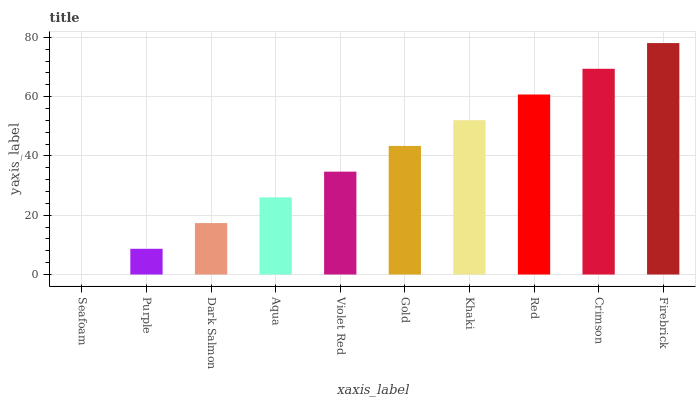Is Purple the minimum?
Answer yes or no. No. Is Purple the maximum?
Answer yes or no. No. Is Purple greater than Seafoam?
Answer yes or no. Yes. Is Seafoam less than Purple?
Answer yes or no. Yes. Is Seafoam greater than Purple?
Answer yes or no. No. Is Purple less than Seafoam?
Answer yes or no. No. Is Gold the high median?
Answer yes or no. Yes. Is Violet Red the low median?
Answer yes or no. Yes. Is Dark Salmon the high median?
Answer yes or no. No. Is Firebrick the low median?
Answer yes or no. No. 